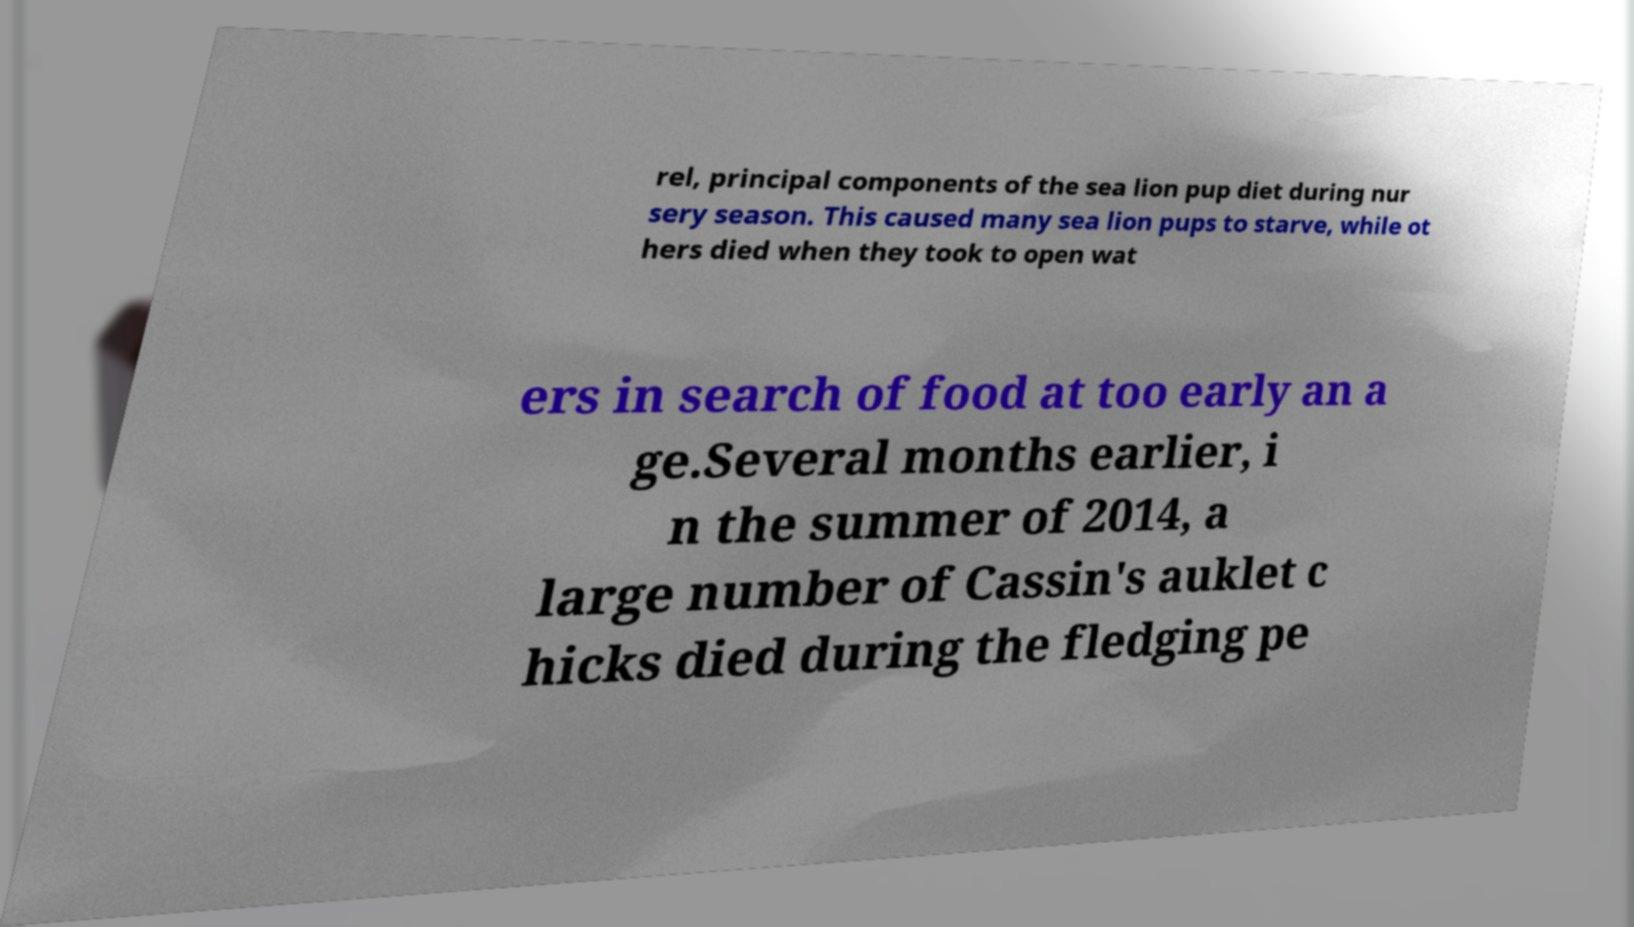Can you read and provide the text displayed in the image?This photo seems to have some interesting text. Can you extract and type it out for me? rel, principal components of the sea lion pup diet during nur sery season. This caused many sea lion pups to starve, while ot hers died when they took to open wat ers in search of food at too early an a ge.Several months earlier, i n the summer of 2014, a large number of Cassin's auklet c hicks died during the fledging pe 